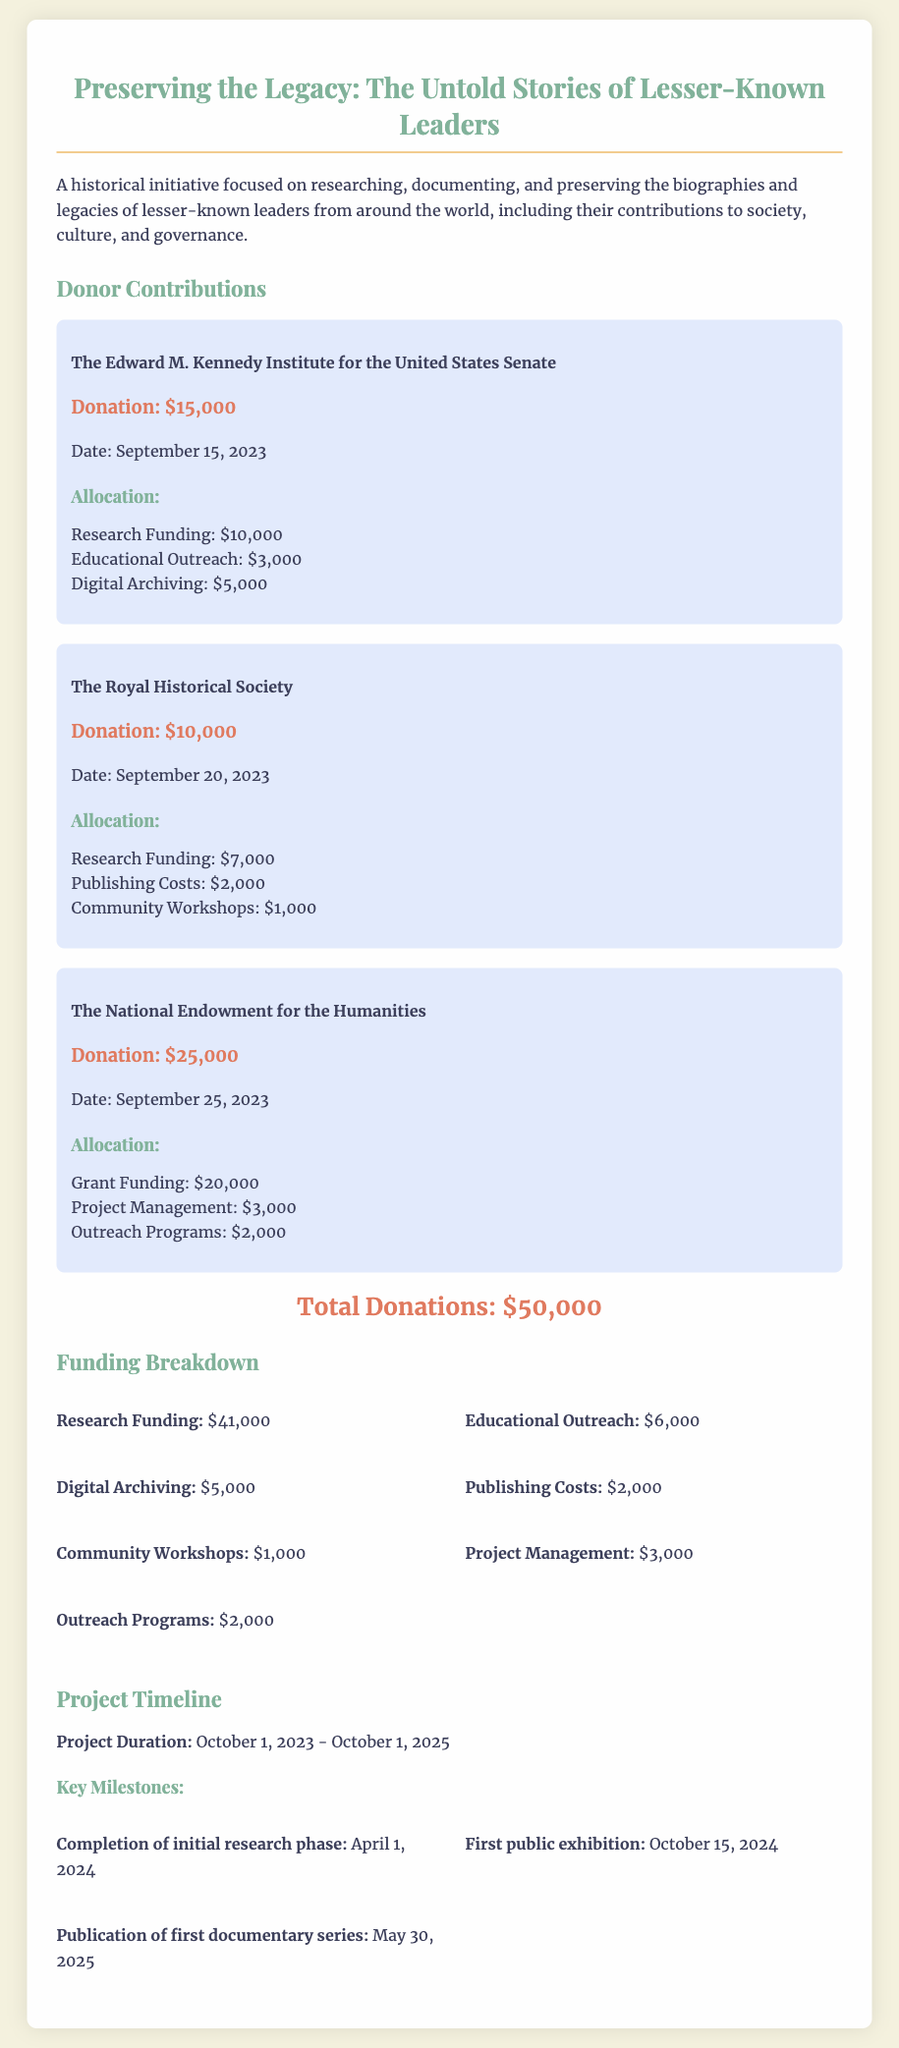What is the total donations received? The total donations are provided at the end of the donor contributions section, which is $15,000 + $10,000 + $25,000 = $50,000.
Answer: $50,000 Who donated the largest amount? The donor with the highest contribution, listed first, is the National Endowment for the Humanities with a donation of $25,000.
Answer: The National Endowment for the Humanities What is the date of the first donation? The first listed donation date is September 15, 2023, from The Edward M. Kennedy Institute for the United States Senate.
Answer: September 15, 2023 How much was allocated for educational outreach? The allocation for educational outreach is detailed in the donor sections, showing a total of $3,000 + $1,000 = $4,000.
Answer: $6,000 What is the completion date for the initial research phase? The timeline section specifies the completion date for the initial research phase as April 1, 2024.
Answer: April 1, 2024 Which organization provided funding for community workshops? The Royal Historical Society allocated $1,000 for community workshops as part of their donation.
Answer: The Royal Historical Society How much funding is allocated to digital archiving? The breakdown shows a total of $5,000 allocated for digital archiving from the donation records.
Answer: $5,000 